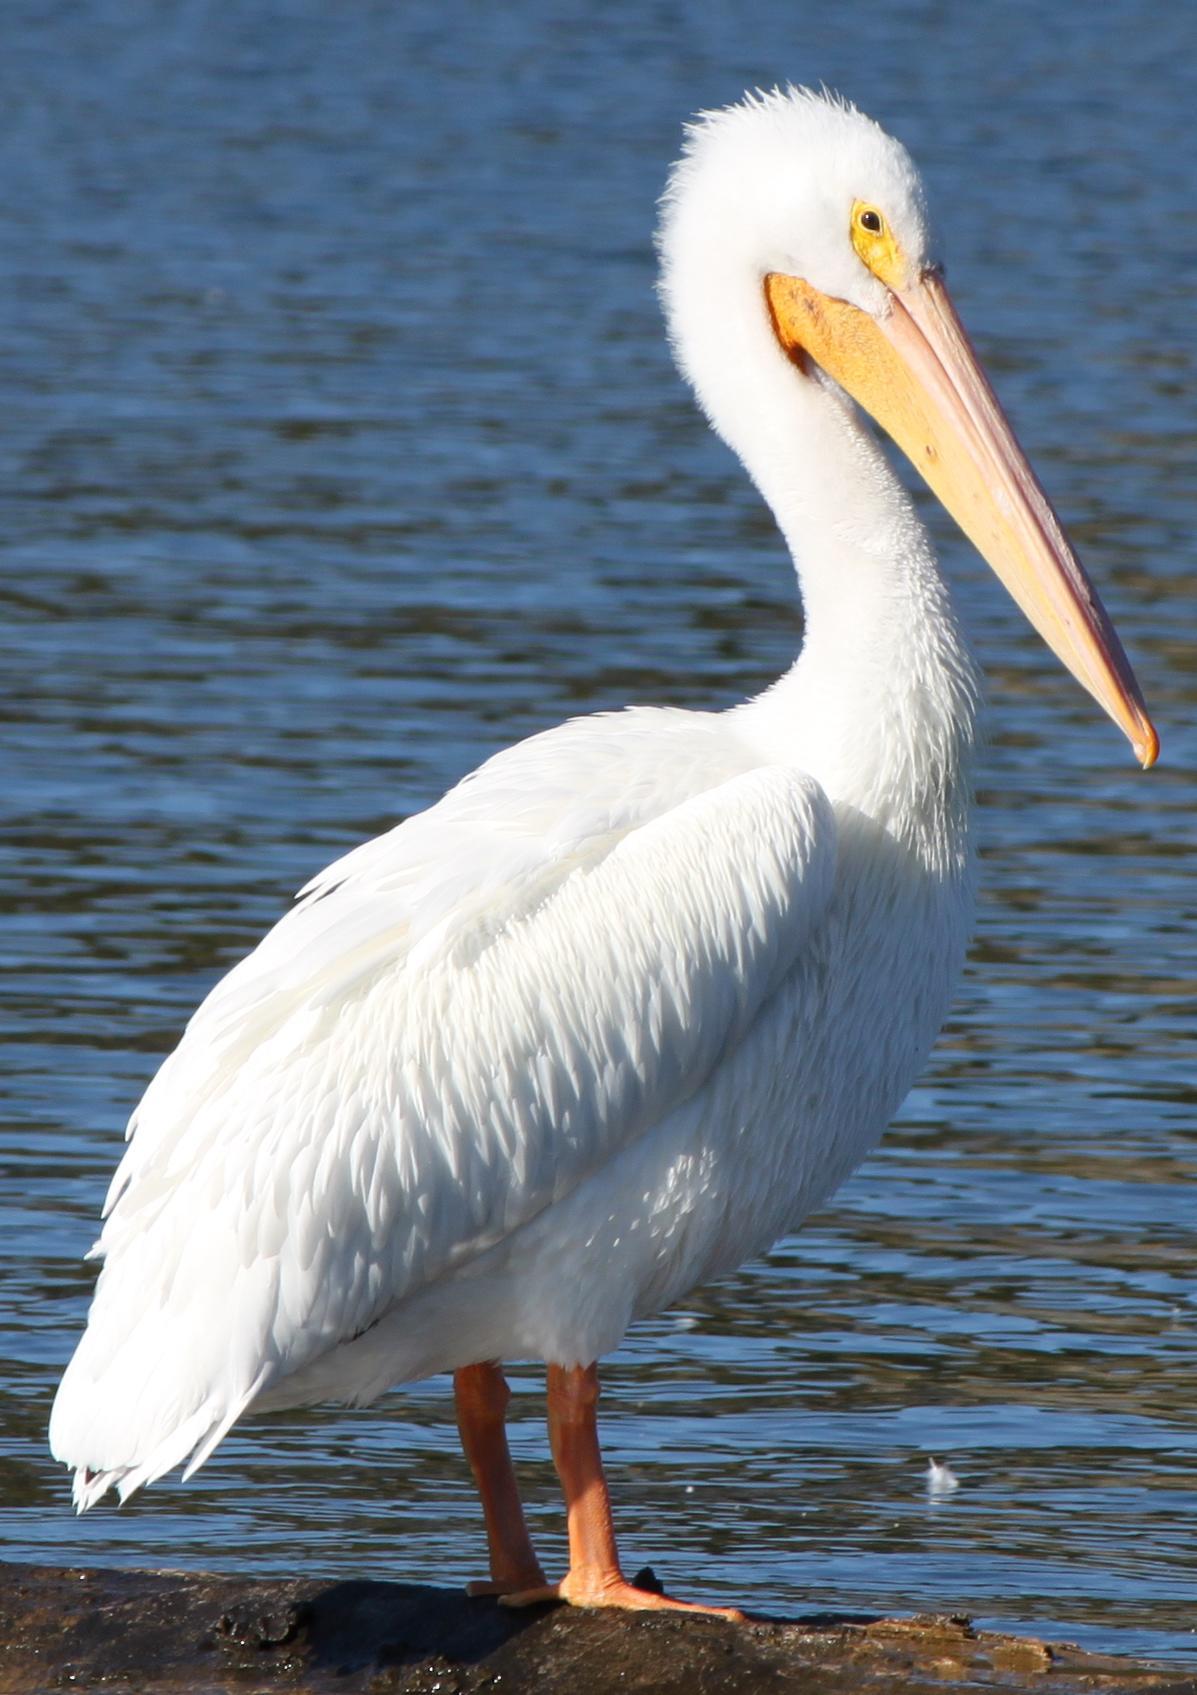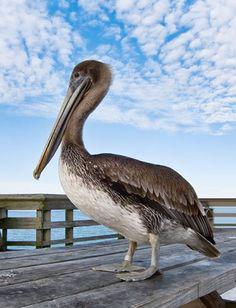The first image is the image on the left, the second image is the image on the right. Assess this claim about the two images: "A bird is sitting on water.". Correct or not? Answer yes or no. No. 